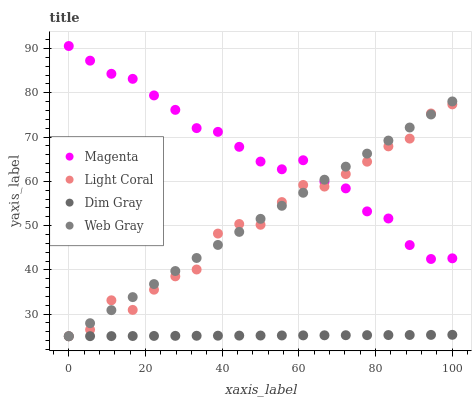Does Dim Gray have the minimum area under the curve?
Answer yes or no. Yes. Does Magenta have the maximum area under the curve?
Answer yes or no. Yes. Does Magenta have the minimum area under the curve?
Answer yes or no. No. Does Dim Gray have the maximum area under the curve?
Answer yes or no. No. Is Dim Gray the smoothest?
Answer yes or no. Yes. Is Light Coral the roughest?
Answer yes or no. Yes. Is Magenta the smoothest?
Answer yes or no. No. Is Magenta the roughest?
Answer yes or no. No. Does Light Coral have the lowest value?
Answer yes or no. Yes. Does Magenta have the lowest value?
Answer yes or no. No. Does Magenta have the highest value?
Answer yes or no. Yes. Does Dim Gray have the highest value?
Answer yes or no. No. Is Dim Gray less than Magenta?
Answer yes or no. Yes. Is Magenta greater than Dim Gray?
Answer yes or no. Yes. Does Light Coral intersect Magenta?
Answer yes or no. Yes. Is Light Coral less than Magenta?
Answer yes or no. No. Is Light Coral greater than Magenta?
Answer yes or no. No. Does Dim Gray intersect Magenta?
Answer yes or no. No. 